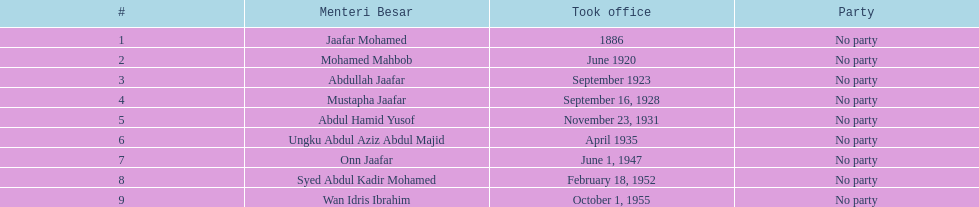Other than abullah jaafar, name someone with the same last name. Mustapha Jaafar. 